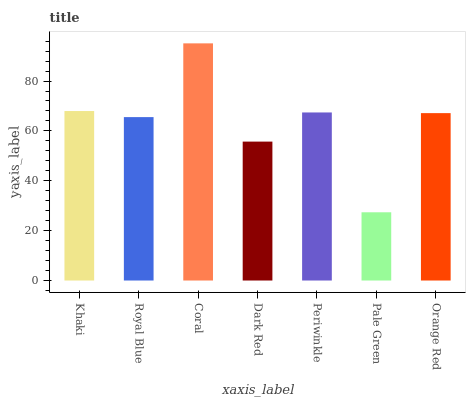Is Pale Green the minimum?
Answer yes or no. Yes. Is Coral the maximum?
Answer yes or no. Yes. Is Royal Blue the minimum?
Answer yes or no. No. Is Royal Blue the maximum?
Answer yes or no. No. Is Khaki greater than Royal Blue?
Answer yes or no. Yes. Is Royal Blue less than Khaki?
Answer yes or no. Yes. Is Royal Blue greater than Khaki?
Answer yes or no. No. Is Khaki less than Royal Blue?
Answer yes or no. No. Is Orange Red the high median?
Answer yes or no. Yes. Is Orange Red the low median?
Answer yes or no. Yes. Is Pale Green the high median?
Answer yes or no. No. Is Pale Green the low median?
Answer yes or no. No. 